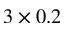<formula> <loc_0><loc_0><loc_500><loc_500>3 \times 0 . 2</formula> 